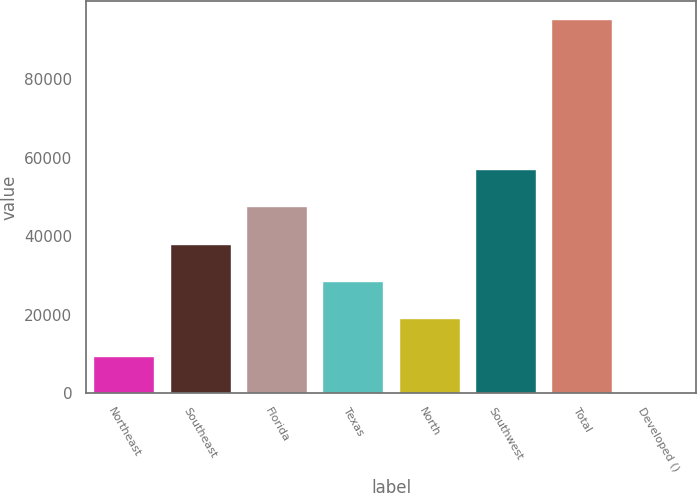Convert chart to OTSL. <chart><loc_0><loc_0><loc_500><loc_500><bar_chart><fcel>Northeast<fcel>Southeast<fcel>Florida<fcel>Texas<fcel>North<fcel>Southwest<fcel>Total<fcel>Developed ()<nl><fcel>9542.8<fcel>38099.2<fcel>47618<fcel>28580.4<fcel>19061.6<fcel>57136.8<fcel>95212<fcel>24<nl></chart> 